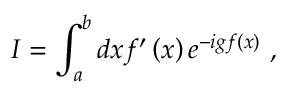Convert formula to latex. <formula><loc_0><loc_0><loc_500><loc_500>I = \int _ { a } ^ { b } d x f ^ { \prime } \left ( x \right ) e ^ { - i g f \left ( x \right ) } \ ,</formula> 